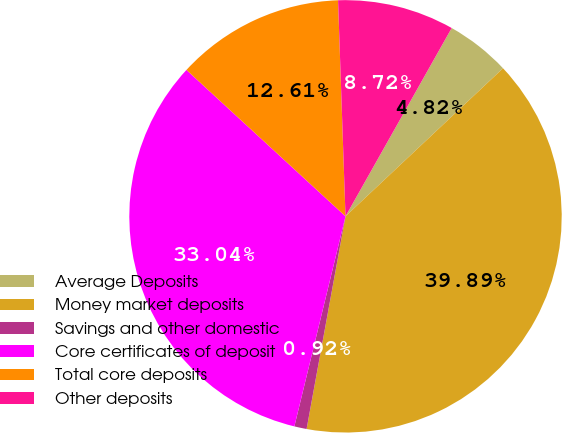<chart> <loc_0><loc_0><loc_500><loc_500><pie_chart><fcel>Average Deposits<fcel>Money market deposits<fcel>Savings and other domestic<fcel>Core certificates of deposit<fcel>Total core deposits<fcel>Other deposits<nl><fcel>4.82%<fcel>39.89%<fcel>0.92%<fcel>33.04%<fcel>12.61%<fcel>8.72%<nl></chart> 